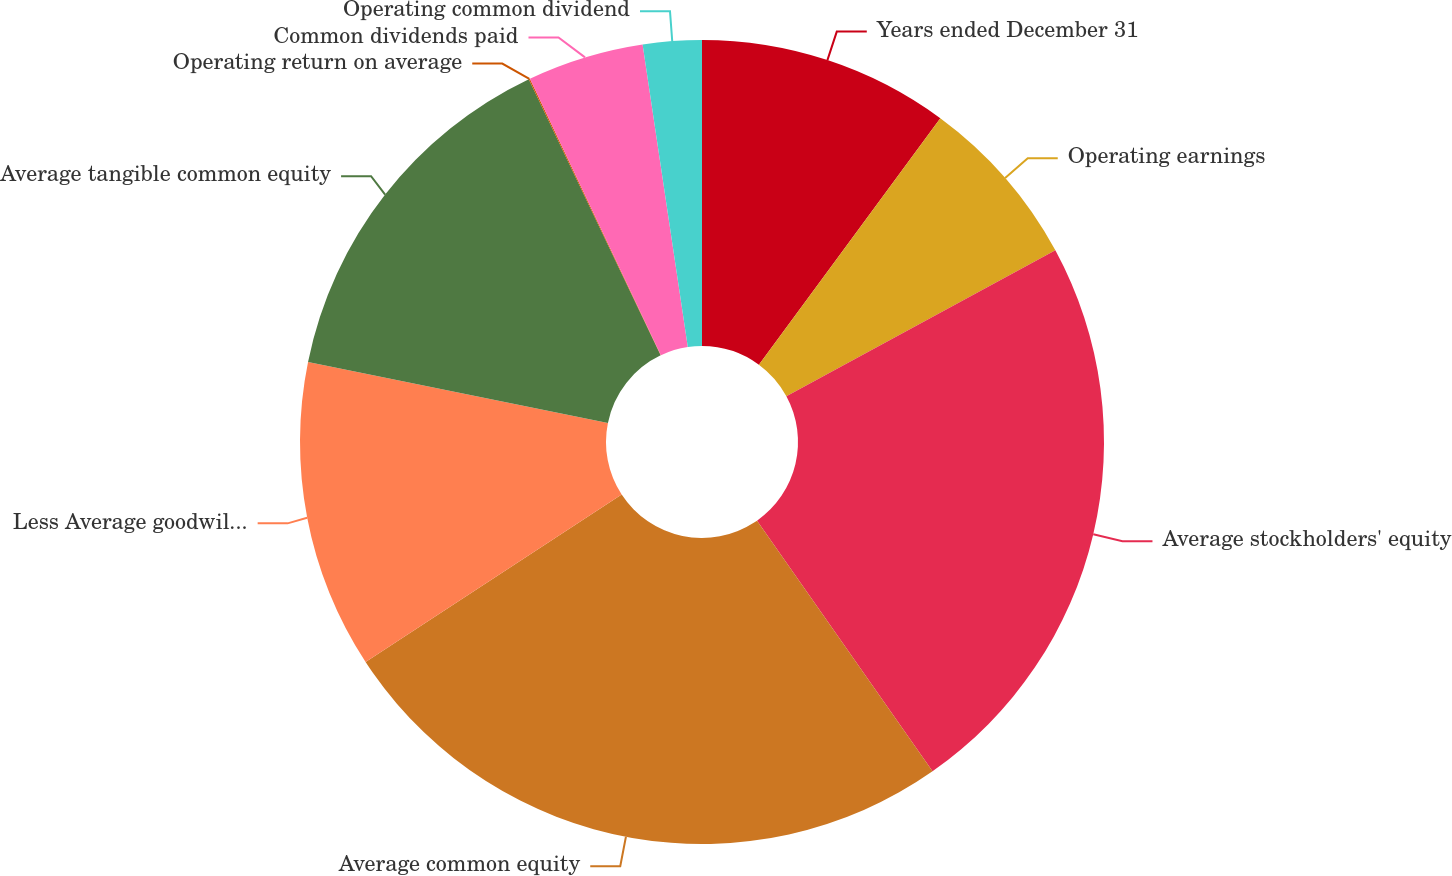<chart> <loc_0><loc_0><loc_500><loc_500><pie_chart><fcel>Years ended December 31<fcel>Operating earnings<fcel>Average stockholders' equity<fcel>Average common equity<fcel>Less Average goodwill and<fcel>Average tangible common equity<fcel>Operating return on average<fcel>Common dividends paid<fcel>Operating common dividend<nl><fcel>10.1%<fcel>6.99%<fcel>23.19%<fcel>25.5%<fcel>12.41%<fcel>14.72%<fcel>0.05%<fcel>4.68%<fcel>2.36%<nl></chart> 